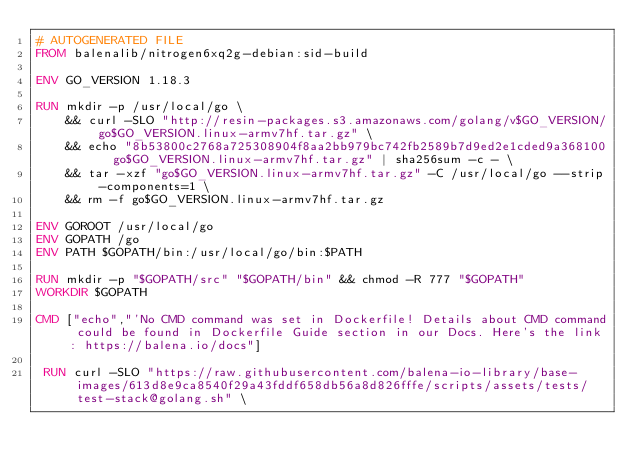<code> <loc_0><loc_0><loc_500><loc_500><_Dockerfile_># AUTOGENERATED FILE
FROM balenalib/nitrogen6xq2g-debian:sid-build

ENV GO_VERSION 1.18.3

RUN mkdir -p /usr/local/go \
	&& curl -SLO "http://resin-packages.s3.amazonaws.com/golang/v$GO_VERSION/go$GO_VERSION.linux-armv7hf.tar.gz" \
	&& echo "8b53800c2768a725308904f8aa2bb979bc742fb2589b7d9ed2e1cded9a368100  go$GO_VERSION.linux-armv7hf.tar.gz" | sha256sum -c - \
	&& tar -xzf "go$GO_VERSION.linux-armv7hf.tar.gz" -C /usr/local/go --strip-components=1 \
	&& rm -f go$GO_VERSION.linux-armv7hf.tar.gz

ENV GOROOT /usr/local/go
ENV GOPATH /go
ENV PATH $GOPATH/bin:/usr/local/go/bin:$PATH

RUN mkdir -p "$GOPATH/src" "$GOPATH/bin" && chmod -R 777 "$GOPATH"
WORKDIR $GOPATH

CMD ["echo","'No CMD command was set in Dockerfile! Details about CMD command could be found in Dockerfile Guide section in our Docs. Here's the link: https://balena.io/docs"]

 RUN curl -SLO "https://raw.githubusercontent.com/balena-io-library/base-images/613d8e9ca8540f29a43fddf658db56a8d826fffe/scripts/assets/tests/test-stack@golang.sh" \</code> 